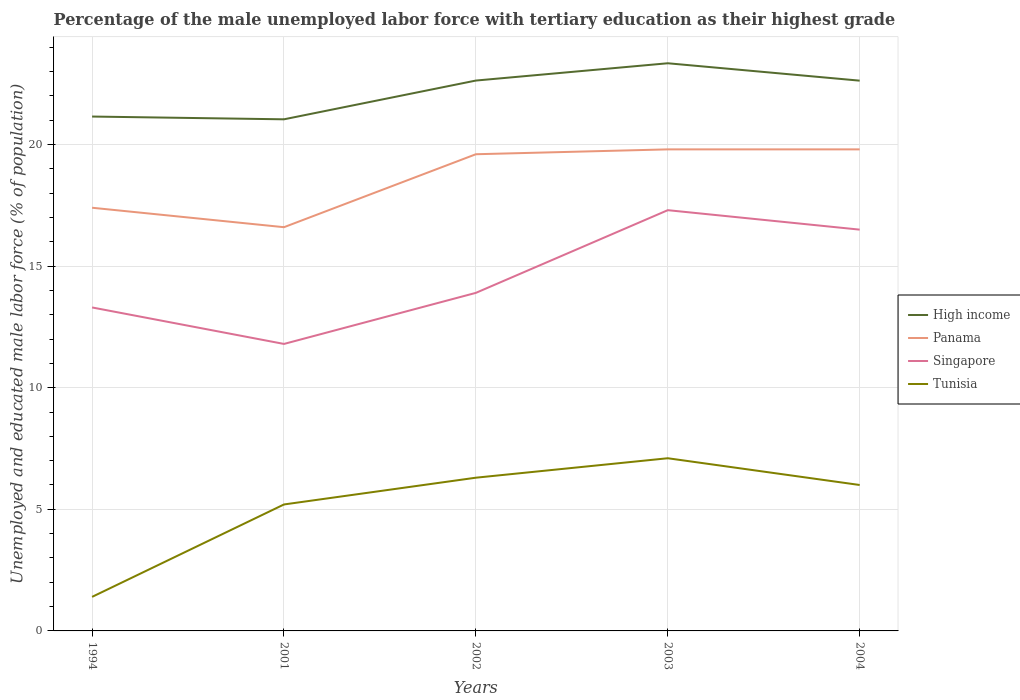Is the number of lines equal to the number of legend labels?
Keep it short and to the point. Yes. Across all years, what is the maximum percentage of the unemployed male labor force with tertiary education in Tunisia?
Ensure brevity in your answer.  1.4. What is the total percentage of the unemployed male labor force with tertiary education in Panama in the graph?
Ensure brevity in your answer.  -3.2. What is the difference between the highest and the second highest percentage of the unemployed male labor force with tertiary education in Panama?
Your response must be concise. 3.2. How many years are there in the graph?
Your answer should be very brief. 5. What is the difference between two consecutive major ticks on the Y-axis?
Offer a very short reply. 5. Does the graph contain any zero values?
Offer a terse response. No. Where does the legend appear in the graph?
Offer a terse response. Center right. How many legend labels are there?
Your answer should be compact. 4. What is the title of the graph?
Provide a short and direct response. Percentage of the male unemployed labor force with tertiary education as their highest grade. What is the label or title of the X-axis?
Your response must be concise. Years. What is the label or title of the Y-axis?
Offer a terse response. Unemployed and educated male labor force (% of population). What is the Unemployed and educated male labor force (% of population) of High income in 1994?
Your answer should be compact. 21.15. What is the Unemployed and educated male labor force (% of population) in Panama in 1994?
Your response must be concise. 17.4. What is the Unemployed and educated male labor force (% of population) in Singapore in 1994?
Offer a very short reply. 13.3. What is the Unemployed and educated male labor force (% of population) of Tunisia in 1994?
Ensure brevity in your answer.  1.4. What is the Unemployed and educated male labor force (% of population) of High income in 2001?
Give a very brief answer. 21.04. What is the Unemployed and educated male labor force (% of population) of Panama in 2001?
Provide a succinct answer. 16.6. What is the Unemployed and educated male labor force (% of population) of Singapore in 2001?
Ensure brevity in your answer.  11.8. What is the Unemployed and educated male labor force (% of population) in Tunisia in 2001?
Your answer should be very brief. 5.2. What is the Unemployed and educated male labor force (% of population) in High income in 2002?
Your answer should be compact. 22.63. What is the Unemployed and educated male labor force (% of population) of Panama in 2002?
Keep it short and to the point. 19.6. What is the Unemployed and educated male labor force (% of population) in Singapore in 2002?
Provide a short and direct response. 13.9. What is the Unemployed and educated male labor force (% of population) of Tunisia in 2002?
Offer a terse response. 6.3. What is the Unemployed and educated male labor force (% of population) of High income in 2003?
Keep it short and to the point. 23.34. What is the Unemployed and educated male labor force (% of population) in Panama in 2003?
Provide a succinct answer. 19.8. What is the Unemployed and educated male labor force (% of population) in Singapore in 2003?
Your response must be concise. 17.3. What is the Unemployed and educated male labor force (% of population) of Tunisia in 2003?
Offer a terse response. 7.1. What is the Unemployed and educated male labor force (% of population) in High income in 2004?
Provide a short and direct response. 22.63. What is the Unemployed and educated male labor force (% of population) in Panama in 2004?
Offer a very short reply. 19.8. What is the Unemployed and educated male labor force (% of population) of Tunisia in 2004?
Your response must be concise. 6. Across all years, what is the maximum Unemployed and educated male labor force (% of population) of High income?
Provide a short and direct response. 23.34. Across all years, what is the maximum Unemployed and educated male labor force (% of population) of Panama?
Your answer should be very brief. 19.8. Across all years, what is the maximum Unemployed and educated male labor force (% of population) of Singapore?
Your response must be concise. 17.3. Across all years, what is the maximum Unemployed and educated male labor force (% of population) of Tunisia?
Keep it short and to the point. 7.1. Across all years, what is the minimum Unemployed and educated male labor force (% of population) of High income?
Your answer should be very brief. 21.04. Across all years, what is the minimum Unemployed and educated male labor force (% of population) of Panama?
Ensure brevity in your answer.  16.6. Across all years, what is the minimum Unemployed and educated male labor force (% of population) of Singapore?
Offer a terse response. 11.8. Across all years, what is the minimum Unemployed and educated male labor force (% of population) of Tunisia?
Your answer should be compact. 1.4. What is the total Unemployed and educated male labor force (% of population) of High income in the graph?
Provide a succinct answer. 110.78. What is the total Unemployed and educated male labor force (% of population) in Panama in the graph?
Offer a terse response. 93.2. What is the total Unemployed and educated male labor force (% of population) of Singapore in the graph?
Give a very brief answer. 72.8. What is the total Unemployed and educated male labor force (% of population) of Tunisia in the graph?
Provide a short and direct response. 26. What is the difference between the Unemployed and educated male labor force (% of population) of High income in 1994 and that in 2001?
Your response must be concise. 0.11. What is the difference between the Unemployed and educated male labor force (% of population) in Panama in 1994 and that in 2001?
Provide a succinct answer. 0.8. What is the difference between the Unemployed and educated male labor force (% of population) in Tunisia in 1994 and that in 2001?
Ensure brevity in your answer.  -3.8. What is the difference between the Unemployed and educated male labor force (% of population) in High income in 1994 and that in 2002?
Provide a short and direct response. -1.48. What is the difference between the Unemployed and educated male labor force (% of population) in Panama in 1994 and that in 2002?
Provide a short and direct response. -2.2. What is the difference between the Unemployed and educated male labor force (% of population) in Singapore in 1994 and that in 2002?
Ensure brevity in your answer.  -0.6. What is the difference between the Unemployed and educated male labor force (% of population) in Tunisia in 1994 and that in 2002?
Provide a succinct answer. -4.9. What is the difference between the Unemployed and educated male labor force (% of population) in High income in 1994 and that in 2003?
Offer a terse response. -2.19. What is the difference between the Unemployed and educated male labor force (% of population) of Panama in 1994 and that in 2003?
Your answer should be very brief. -2.4. What is the difference between the Unemployed and educated male labor force (% of population) of Singapore in 1994 and that in 2003?
Your answer should be very brief. -4. What is the difference between the Unemployed and educated male labor force (% of population) of Tunisia in 1994 and that in 2003?
Your answer should be compact. -5.7. What is the difference between the Unemployed and educated male labor force (% of population) in High income in 1994 and that in 2004?
Provide a short and direct response. -1.48. What is the difference between the Unemployed and educated male labor force (% of population) of Panama in 1994 and that in 2004?
Offer a terse response. -2.4. What is the difference between the Unemployed and educated male labor force (% of population) of High income in 2001 and that in 2002?
Give a very brief answer. -1.59. What is the difference between the Unemployed and educated male labor force (% of population) of Panama in 2001 and that in 2002?
Provide a short and direct response. -3. What is the difference between the Unemployed and educated male labor force (% of population) of High income in 2001 and that in 2003?
Give a very brief answer. -2.3. What is the difference between the Unemployed and educated male labor force (% of population) of Panama in 2001 and that in 2003?
Make the answer very short. -3.2. What is the difference between the Unemployed and educated male labor force (% of population) in Singapore in 2001 and that in 2003?
Ensure brevity in your answer.  -5.5. What is the difference between the Unemployed and educated male labor force (% of population) of Tunisia in 2001 and that in 2003?
Your response must be concise. -1.9. What is the difference between the Unemployed and educated male labor force (% of population) in High income in 2001 and that in 2004?
Ensure brevity in your answer.  -1.59. What is the difference between the Unemployed and educated male labor force (% of population) of Singapore in 2001 and that in 2004?
Offer a terse response. -4.7. What is the difference between the Unemployed and educated male labor force (% of population) of Tunisia in 2001 and that in 2004?
Your response must be concise. -0.8. What is the difference between the Unemployed and educated male labor force (% of population) of High income in 2002 and that in 2003?
Offer a very short reply. -0.71. What is the difference between the Unemployed and educated male labor force (% of population) in Panama in 2002 and that in 2003?
Provide a succinct answer. -0.2. What is the difference between the Unemployed and educated male labor force (% of population) in Singapore in 2002 and that in 2003?
Give a very brief answer. -3.4. What is the difference between the Unemployed and educated male labor force (% of population) of Tunisia in 2002 and that in 2003?
Your response must be concise. -0.8. What is the difference between the Unemployed and educated male labor force (% of population) in High income in 2002 and that in 2004?
Your answer should be very brief. 0. What is the difference between the Unemployed and educated male labor force (% of population) in Singapore in 2002 and that in 2004?
Your answer should be compact. -2.6. What is the difference between the Unemployed and educated male labor force (% of population) of High income in 2003 and that in 2004?
Provide a succinct answer. 0.72. What is the difference between the Unemployed and educated male labor force (% of population) of Singapore in 2003 and that in 2004?
Your answer should be very brief. 0.8. What is the difference between the Unemployed and educated male labor force (% of population) in High income in 1994 and the Unemployed and educated male labor force (% of population) in Panama in 2001?
Your answer should be compact. 4.55. What is the difference between the Unemployed and educated male labor force (% of population) in High income in 1994 and the Unemployed and educated male labor force (% of population) in Singapore in 2001?
Ensure brevity in your answer.  9.35. What is the difference between the Unemployed and educated male labor force (% of population) in High income in 1994 and the Unemployed and educated male labor force (% of population) in Tunisia in 2001?
Give a very brief answer. 15.95. What is the difference between the Unemployed and educated male labor force (% of population) of Panama in 1994 and the Unemployed and educated male labor force (% of population) of Singapore in 2001?
Provide a short and direct response. 5.6. What is the difference between the Unemployed and educated male labor force (% of population) of Panama in 1994 and the Unemployed and educated male labor force (% of population) of Tunisia in 2001?
Your answer should be very brief. 12.2. What is the difference between the Unemployed and educated male labor force (% of population) in Singapore in 1994 and the Unemployed and educated male labor force (% of population) in Tunisia in 2001?
Your answer should be compact. 8.1. What is the difference between the Unemployed and educated male labor force (% of population) of High income in 1994 and the Unemployed and educated male labor force (% of population) of Panama in 2002?
Your response must be concise. 1.55. What is the difference between the Unemployed and educated male labor force (% of population) of High income in 1994 and the Unemployed and educated male labor force (% of population) of Singapore in 2002?
Your answer should be compact. 7.25. What is the difference between the Unemployed and educated male labor force (% of population) in High income in 1994 and the Unemployed and educated male labor force (% of population) in Tunisia in 2002?
Make the answer very short. 14.85. What is the difference between the Unemployed and educated male labor force (% of population) of Singapore in 1994 and the Unemployed and educated male labor force (% of population) of Tunisia in 2002?
Your answer should be compact. 7. What is the difference between the Unemployed and educated male labor force (% of population) of High income in 1994 and the Unemployed and educated male labor force (% of population) of Panama in 2003?
Your response must be concise. 1.35. What is the difference between the Unemployed and educated male labor force (% of population) in High income in 1994 and the Unemployed and educated male labor force (% of population) in Singapore in 2003?
Keep it short and to the point. 3.85. What is the difference between the Unemployed and educated male labor force (% of population) in High income in 1994 and the Unemployed and educated male labor force (% of population) in Tunisia in 2003?
Give a very brief answer. 14.05. What is the difference between the Unemployed and educated male labor force (% of population) of Panama in 1994 and the Unemployed and educated male labor force (% of population) of Singapore in 2003?
Provide a succinct answer. 0.1. What is the difference between the Unemployed and educated male labor force (% of population) in Panama in 1994 and the Unemployed and educated male labor force (% of population) in Tunisia in 2003?
Your answer should be compact. 10.3. What is the difference between the Unemployed and educated male labor force (% of population) in Singapore in 1994 and the Unemployed and educated male labor force (% of population) in Tunisia in 2003?
Give a very brief answer. 6.2. What is the difference between the Unemployed and educated male labor force (% of population) of High income in 1994 and the Unemployed and educated male labor force (% of population) of Panama in 2004?
Your answer should be compact. 1.35. What is the difference between the Unemployed and educated male labor force (% of population) of High income in 1994 and the Unemployed and educated male labor force (% of population) of Singapore in 2004?
Your response must be concise. 4.65. What is the difference between the Unemployed and educated male labor force (% of population) of High income in 1994 and the Unemployed and educated male labor force (% of population) of Tunisia in 2004?
Keep it short and to the point. 15.15. What is the difference between the Unemployed and educated male labor force (% of population) of High income in 2001 and the Unemployed and educated male labor force (% of population) of Panama in 2002?
Your answer should be compact. 1.44. What is the difference between the Unemployed and educated male labor force (% of population) in High income in 2001 and the Unemployed and educated male labor force (% of population) in Singapore in 2002?
Your answer should be very brief. 7.14. What is the difference between the Unemployed and educated male labor force (% of population) in High income in 2001 and the Unemployed and educated male labor force (% of population) in Tunisia in 2002?
Provide a short and direct response. 14.74. What is the difference between the Unemployed and educated male labor force (% of population) of Panama in 2001 and the Unemployed and educated male labor force (% of population) of Tunisia in 2002?
Provide a succinct answer. 10.3. What is the difference between the Unemployed and educated male labor force (% of population) in Singapore in 2001 and the Unemployed and educated male labor force (% of population) in Tunisia in 2002?
Your response must be concise. 5.5. What is the difference between the Unemployed and educated male labor force (% of population) in High income in 2001 and the Unemployed and educated male labor force (% of population) in Panama in 2003?
Your answer should be very brief. 1.24. What is the difference between the Unemployed and educated male labor force (% of population) in High income in 2001 and the Unemployed and educated male labor force (% of population) in Singapore in 2003?
Give a very brief answer. 3.74. What is the difference between the Unemployed and educated male labor force (% of population) of High income in 2001 and the Unemployed and educated male labor force (% of population) of Tunisia in 2003?
Keep it short and to the point. 13.94. What is the difference between the Unemployed and educated male labor force (% of population) in Panama in 2001 and the Unemployed and educated male labor force (% of population) in Singapore in 2003?
Your answer should be compact. -0.7. What is the difference between the Unemployed and educated male labor force (% of population) in Panama in 2001 and the Unemployed and educated male labor force (% of population) in Tunisia in 2003?
Provide a short and direct response. 9.5. What is the difference between the Unemployed and educated male labor force (% of population) in Singapore in 2001 and the Unemployed and educated male labor force (% of population) in Tunisia in 2003?
Offer a terse response. 4.7. What is the difference between the Unemployed and educated male labor force (% of population) in High income in 2001 and the Unemployed and educated male labor force (% of population) in Panama in 2004?
Give a very brief answer. 1.24. What is the difference between the Unemployed and educated male labor force (% of population) of High income in 2001 and the Unemployed and educated male labor force (% of population) of Singapore in 2004?
Ensure brevity in your answer.  4.54. What is the difference between the Unemployed and educated male labor force (% of population) of High income in 2001 and the Unemployed and educated male labor force (% of population) of Tunisia in 2004?
Provide a succinct answer. 15.04. What is the difference between the Unemployed and educated male labor force (% of population) of Panama in 2001 and the Unemployed and educated male labor force (% of population) of Tunisia in 2004?
Your response must be concise. 10.6. What is the difference between the Unemployed and educated male labor force (% of population) in High income in 2002 and the Unemployed and educated male labor force (% of population) in Panama in 2003?
Make the answer very short. 2.83. What is the difference between the Unemployed and educated male labor force (% of population) in High income in 2002 and the Unemployed and educated male labor force (% of population) in Singapore in 2003?
Your response must be concise. 5.33. What is the difference between the Unemployed and educated male labor force (% of population) of High income in 2002 and the Unemployed and educated male labor force (% of population) of Tunisia in 2003?
Ensure brevity in your answer.  15.53. What is the difference between the Unemployed and educated male labor force (% of population) of Panama in 2002 and the Unemployed and educated male labor force (% of population) of Singapore in 2003?
Offer a very short reply. 2.3. What is the difference between the Unemployed and educated male labor force (% of population) of Singapore in 2002 and the Unemployed and educated male labor force (% of population) of Tunisia in 2003?
Your response must be concise. 6.8. What is the difference between the Unemployed and educated male labor force (% of population) of High income in 2002 and the Unemployed and educated male labor force (% of population) of Panama in 2004?
Provide a succinct answer. 2.83. What is the difference between the Unemployed and educated male labor force (% of population) in High income in 2002 and the Unemployed and educated male labor force (% of population) in Singapore in 2004?
Give a very brief answer. 6.13. What is the difference between the Unemployed and educated male labor force (% of population) in High income in 2002 and the Unemployed and educated male labor force (% of population) in Tunisia in 2004?
Offer a very short reply. 16.63. What is the difference between the Unemployed and educated male labor force (% of population) in High income in 2003 and the Unemployed and educated male labor force (% of population) in Panama in 2004?
Keep it short and to the point. 3.54. What is the difference between the Unemployed and educated male labor force (% of population) in High income in 2003 and the Unemployed and educated male labor force (% of population) in Singapore in 2004?
Ensure brevity in your answer.  6.84. What is the difference between the Unemployed and educated male labor force (% of population) in High income in 2003 and the Unemployed and educated male labor force (% of population) in Tunisia in 2004?
Offer a terse response. 17.34. What is the difference between the Unemployed and educated male labor force (% of population) in Panama in 2003 and the Unemployed and educated male labor force (% of population) in Singapore in 2004?
Your answer should be compact. 3.3. What is the difference between the Unemployed and educated male labor force (% of population) of Singapore in 2003 and the Unemployed and educated male labor force (% of population) of Tunisia in 2004?
Keep it short and to the point. 11.3. What is the average Unemployed and educated male labor force (% of population) in High income per year?
Provide a short and direct response. 22.16. What is the average Unemployed and educated male labor force (% of population) in Panama per year?
Provide a succinct answer. 18.64. What is the average Unemployed and educated male labor force (% of population) of Singapore per year?
Keep it short and to the point. 14.56. In the year 1994, what is the difference between the Unemployed and educated male labor force (% of population) of High income and Unemployed and educated male labor force (% of population) of Panama?
Ensure brevity in your answer.  3.75. In the year 1994, what is the difference between the Unemployed and educated male labor force (% of population) of High income and Unemployed and educated male labor force (% of population) of Singapore?
Give a very brief answer. 7.85. In the year 1994, what is the difference between the Unemployed and educated male labor force (% of population) of High income and Unemployed and educated male labor force (% of population) of Tunisia?
Offer a terse response. 19.75. In the year 1994, what is the difference between the Unemployed and educated male labor force (% of population) of Panama and Unemployed and educated male labor force (% of population) of Singapore?
Provide a short and direct response. 4.1. In the year 1994, what is the difference between the Unemployed and educated male labor force (% of population) in Panama and Unemployed and educated male labor force (% of population) in Tunisia?
Ensure brevity in your answer.  16. In the year 1994, what is the difference between the Unemployed and educated male labor force (% of population) of Singapore and Unemployed and educated male labor force (% of population) of Tunisia?
Offer a terse response. 11.9. In the year 2001, what is the difference between the Unemployed and educated male labor force (% of population) of High income and Unemployed and educated male labor force (% of population) of Panama?
Make the answer very short. 4.44. In the year 2001, what is the difference between the Unemployed and educated male labor force (% of population) in High income and Unemployed and educated male labor force (% of population) in Singapore?
Provide a succinct answer. 9.24. In the year 2001, what is the difference between the Unemployed and educated male labor force (% of population) in High income and Unemployed and educated male labor force (% of population) in Tunisia?
Ensure brevity in your answer.  15.84. In the year 2001, what is the difference between the Unemployed and educated male labor force (% of population) of Panama and Unemployed and educated male labor force (% of population) of Tunisia?
Offer a terse response. 11.4. In the year 2002, what is the difference between the Unemployed and educated male labor force (% of population) in High income and Unemployed and educated male labor force (% of population) in Panama?
Your answer should be compact. 3.03. In the year 2002, what is the difference between the Unemployed and educated male labor force (% of population) in High income and Unemployed and educated male labor force (% of population) in Singapore?
Your answer should be compact. 8.73. In the year 2002, what is the difference between the Unemployed and educated male labor force (% of population) in High income and Unemployed and educated male labor force (% of population) in Tunisia?
Make the answer very short. 16.33. In the year 2003, what is the difference between the Unemployed and educated male labor force (% of population) of High income and Unemployed and educated male labor force (% of population) of Panama?
Ensure brevity in your answer.  3.54. In the year 2003, what is the difference between the Unemployed and educated male labor force (% of population) of High income and Unemployed and educated male labor force (% of population) of Singapore?
Your answer should be very brief. 6.04. In the year 2003, what is the difference between the Unemployed and educated male labor force (% of population) in High income and Unemployed and educated male labor force (% of population) in Tunisia?
Offer a very short reply. 16.24. In the year 2003, what is the difference between the Unemployed and educated male labor force (% of population) in Panama and Unemployed and educated male labor force (% of population) in Tunisia?
Make the answer very short. 12.7. In the year 2003, what is the difference between the Unemployed and educated male labor force (% of population) of Singapore and Unemployed and educated male labor force (% of population) of Tunisia?
Your answer should be compact. 10.2. In the year 2004, what is the difference between the Unemployed and educated male labor force (% of population) of High income and Unemployed and educated male labor force (% of population) of Panama?
Provide a succinct answer. 2.83. In the year 2004, what is the difference between the Unemployed and educated male labor force (% of population) in High income and Unemployed and educated male labor force (% of population) in Singapore?
Offer a terse response. 6.13. In the year 2004, what is the difference between the Unemployed and educated male labor force (% of population) in High income and Unemployed and educated male labor force (% of population) in Tunisia?
Your answer should be compact. 16.63. In the year 2004, what is the difference between the Unemployed and educated male labor force (% of population) of Panama and Unemployed and educated male labor force (% of population) of Singapore?
Your answer should be very brief. 3.3. In the year 2004, what is the difference between the Unemployed and educated male labor force (% of population) of Panama and Unemployed and educated male labor force (% of population) of Tunisia?
Offer a terse response. 13.8. In the year 2004, what is the difference between the Unemployed and educated male labor force (% of population) in Singapore and Unemployed and educated male labor force (% of population) in Tunisia?
Offer a very short reply. 10.5. What is the ratio of the Unemployed and educated male labor force (% of population) of High income in 1994 to that in 2001?
Your response must be concise. 1.01. What is the ratio of the Unemployed and educated male labor force (% of population) in Panama in 1994 to that in 2001?
Provide a short and direct response. 1.05. What is the ratio of the Unemployed and educated male labor force (% of population) of Singapore in 1994 to that in 2001?
Make the answer very short. 1.13. What is the ratio of the Unemployed and educated male labor force (% of population) in Tunisia in 1994 to that in 2001?
Offer a terse response. 0.27. What is the ratio of the Unemployed and educated male labor force (% of population) of High income in 1994 to that in 2002?
Give a very brief answer. 0.93. What is the ratio of the Unemployed and educated male labor force (% of population) of Panama in 1994 to that in 2002?
Provide a succinct answer. 0.89. What is the ratio of the Unemployed and educated male labor force (% of population) in Singapore in 1994 to that in 2002?
Provide a short and direct response. 0.96. What is the ratio of the Unemployed and educated male labor force (% of population) in Tunisia in 1994 to that in 2002?
Ensure brevity in your answer.  0.22. What is the ratio of the Unemployed and educated male labor force (% of population) in High income in 1994 to that in 2003?
Your answer should be very brief. 0.91. What is the ratio of the Unemployed and educated male labor force (% of population) in Panama in 1994 to that in 2003?
Keep it short and to the point. 0.88. What is the ratio of the Unemployed and educated male labor force (% of population) in Singapore in 1994 to that in 2003?
Give a very brief answer. 0.77. What is the ratio of the Unemployed and educated male labor force (% of population) in Tunisia in 1994 to that in 2003?
Provide a short and direct response. 0.2. What is the ratio of the Unemployed and educated male labor force (% of population) of High income in 1994 to that in 2004?
Give a very brief answer. 0.93. What is the ratio of the Unemployed and educated male labor force (% of population) in Panama in 1994 to that in 2004?
Offer a very short reply. 0.88. What is the ratio of the Unemployed and educated male labor force (% of population) in Singapore in 1994 to that in 2004?
Ensure brevity in your answer.  0.81. What is the ratio of the Unemployed and educated male labor force (% of population) in Tunisia in 1994 to that in 2004?
Provide a succinct answer. 0.23. What is the ratio of the Unemployed and educated male labor force (% of population) in High income in 2001 to that in 2002?
Keep it short and to the point. 0.93. What is the ratio of the Unemployed and educated male labor force (% of population) of Panama in 2001 to that in 2002?
Your answer should be compact. 0.85. What is the ratio of the Unemployed and educated male labor force (% of population) of Singapore in 2001 to that in 2002?
Your answer should be compact. 0.85. What is the ratio of the Unemployed and educated male labor force (% of population) in Tunisia in 2001 to that in 2002?
Ensure brevity in your answer.  0.83. What is the ratio of the Unemployed and educated male labor force (% of population) of High income in 2001 to that in 2003?
Provide a short and direct response. 0.9. What is the ratio of the Unemployed and educated male labor force (% of population) in Panama in 2001 to that in 2003?
Keep it short and to the point. 0.84. What is the ratio of the Unemployed and educated male labor force (% of population) in Singapore in 2001 to that in 2003?
Provide a short and direct response. 0.68. What is the ratio of the Unemployed and educated male labor force (% of population) in Tunisia in 2001 to that in 2003?
Keep it short and to the point. 0.73. What is the ratio of the Unemployed and educated male labor force (% of population) of High income in 2001 to that in 2004?
Keep it short and to the point. 0.93. What is the ratio of the Unemployed and educated male labor force (% of population) in Panama in 2001 to that in 2004?
Your answer should be very brief. 0.84. What is the ratio of the Unemployed and educated male labor force (% of population) of Singapore in 2001 to that in 2004?
Your answer should be very brief. 0.72. What is the ratio of the Unemployed and educated male labor force (% of population) in Tunisia in 2001 to that in 2004?
Ensure brevity in your answer.  0.87. What is the ratio of the Unemployed and educated male labor force (% of population) in High income in 2002 to that in 2003?
Provide a succinct answer. 0.97. What is the ratio of the Unemployed and educated male labor force (% of population) of Singapore in 2002 to that in 2003?
Provide a succinct answer. 0.8. What is the ratio of the Unemployed and educated male labor force (% of population) in Tunisia in 2002 to that in 2003?
Provide a succinct answer. 0.89. What is the ratio of the Unemployed and educated male labor force (% of population) in Panama in 2002 to that in 2004?
Your answer should be compact. 0.99. What is the ratio of the Unemployed and educated male labor force (% of population) in Singapore in 2002 to that in 2004?
Provide a short and direct response. 0.84. What is the ratio of the Unemployed and educated male labor force (% of population) of High income in 2003 to that in 2004?
Provide a short and direct response. 1.03. What is the ratio of the Unemployed and educated male labor force (% of population) in Panama in 2003 to that in 2004?
Provide a short and direct response. 1. What is the ratio of the Unemployed and educated male labor force (% of population) of Singapore in 2003 to that in 2004?
Provide a short and direct response. 1.05. What is the ratio of the Unemployed and educated male labor force (% of population) of Tunisia in 2003 to that in 2004?
Provide a short and direct response. 1.18. What is the difference between the highest and the second highest Unemployed and educated male labor force (% of population) in High income?
Your answer should be very brief. 0.71. What is the difference between the highest and the second highest Unemployed and educated male labor force (% of population) in Panama?
Make the answer very short. 0. What is the difference between the highest and the second highest Unemployed and educated male labor force (% of population) of Singapore?
Your answer should be very brief. 0.8. What is the difference between the highest and the lowest Unemployed and educated male labor force (% of population) in High income?
Offer a terse response. 2.3. What is the difference between the highest and the lowest Unemployed and educated male labor force (% of population) in Singapore?
Your answer should be compact. 5.5. 